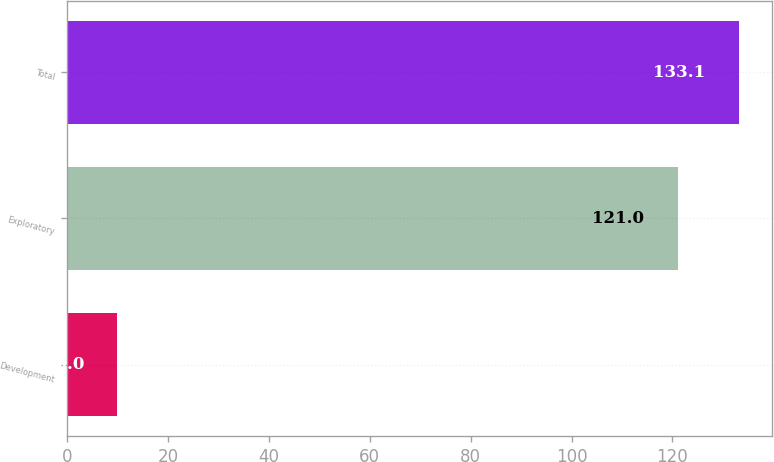<chart> <loc_0><loc_0><loc_500><loc_500><bar_chart><fcel>Development<fcel>Exploratory<fcel>Total<nl><fcel>10<fcel>121<fcel>133.1<nl></chart> 